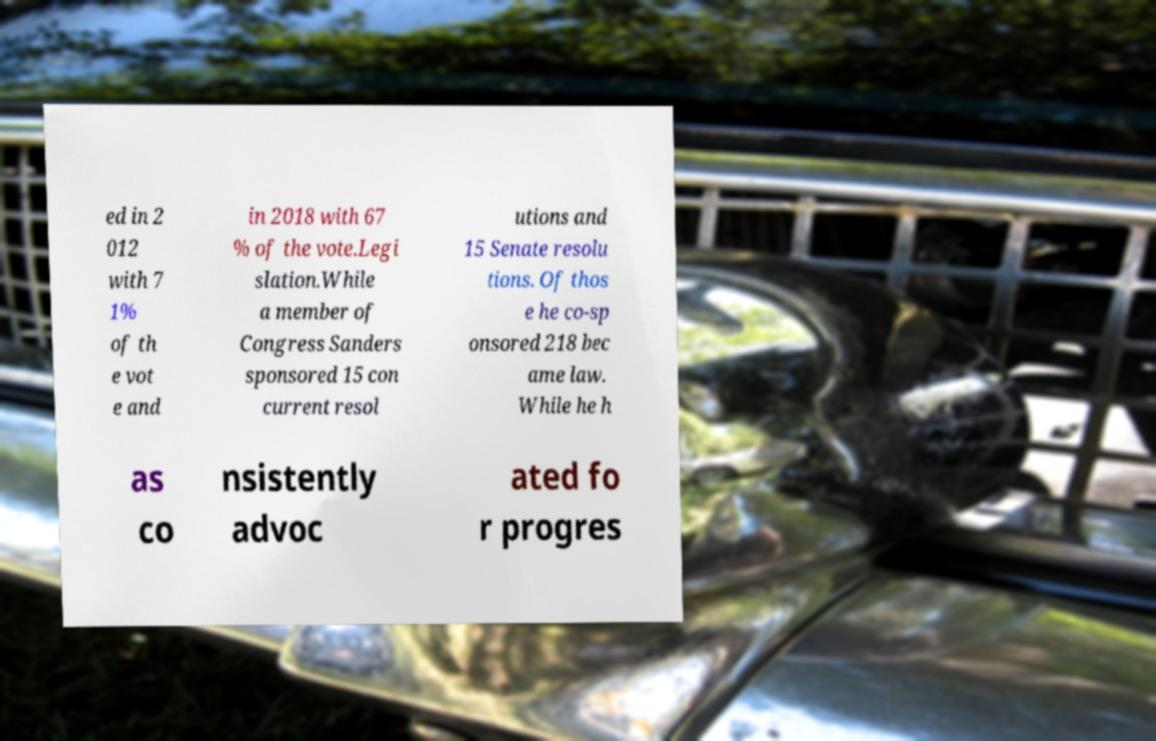Could you assist in decoding the text presented in this image and type it out clearly? ed in 2 012 with 7 1% of th e vot e and in 2018 with 67 % of the vote.Legi slation.While a member of Congress Sanders sponsored 15 con current resol utions and 15 Senate resolu tions. Of thos e he co-sp onsored 218 bec ame law. While he h as co nsistently advoc ated fo r progres 